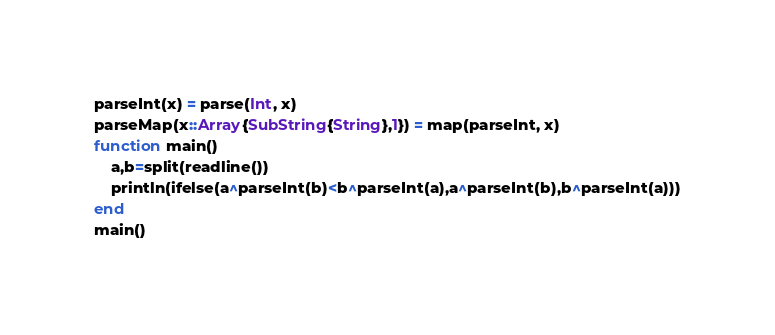Convert code to text. <code><loc_0><loc_0><loc_500><loc_500><_Julia_>parseInt(x) = parse(Int, x)
parseMap(x::Array{SubString{String},1}) = map(parseInt, x)
function main()
    a,b=split(readline())
    println(ifelse(a^parseInt(b)<b^parseInt(a),a^parseInt(b),b^parseInt(a)))
end
main()</code> 